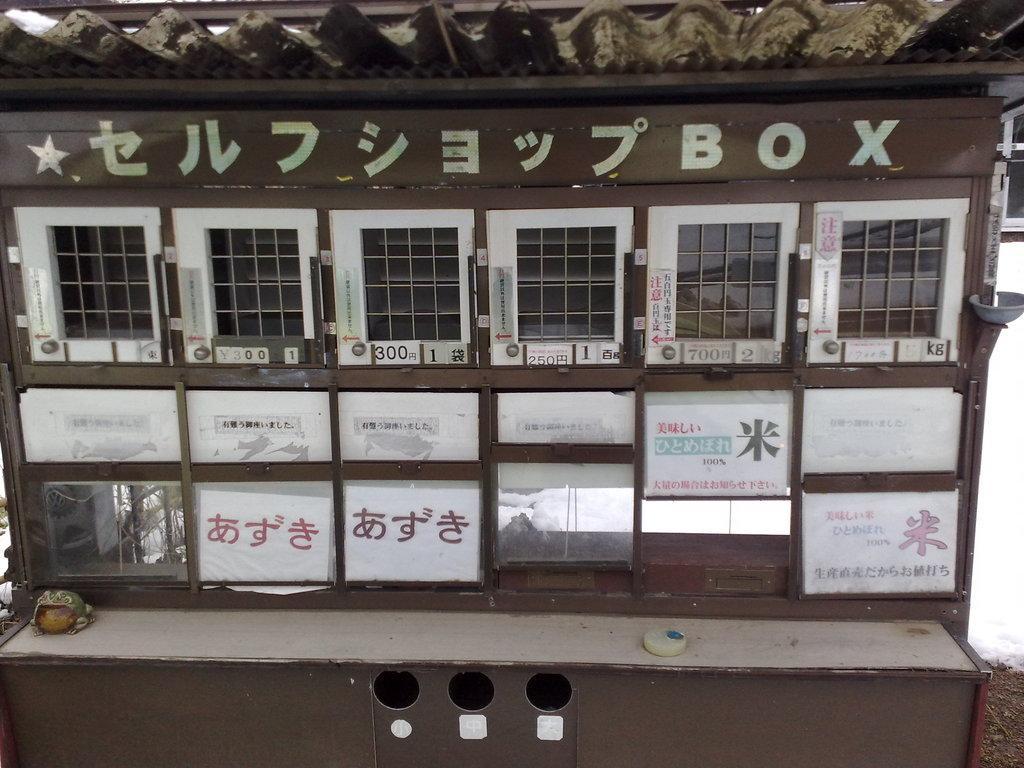Could you give a brief overview of what you see in this image? In this picture we can see small doors, posters and glass. We can see objects on the platform and sheet. 